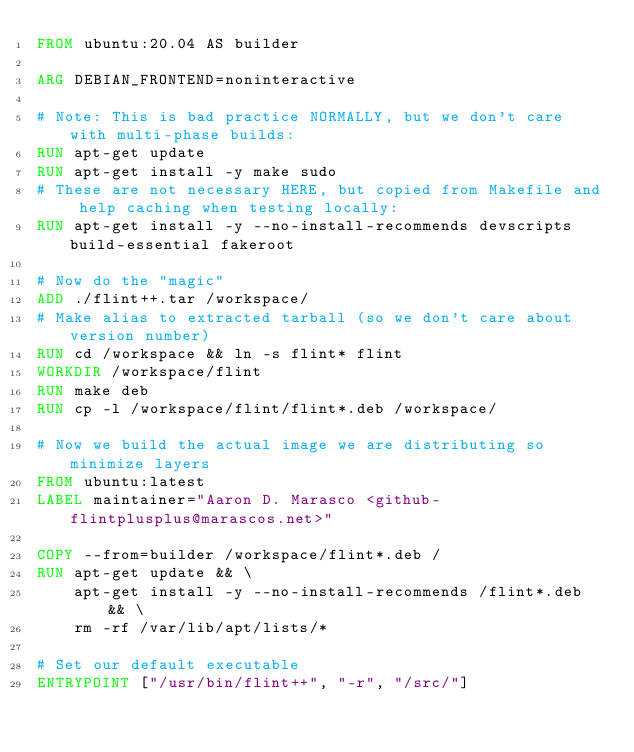<code> <loc_0><loc_0><loc_500><loc_500><_Dockerfile_>FROM ubuntu:20.04 AS builder

ARG DEBIAN_FRONTEND=noninteractive

# Note: This is bad practice NORMALLY, but we don't care with multi-phase builds:
RUN apt-get update
RUN apt-get install -y make sudo
# These are not necessary HERE, but copied from Makefile and help caching when testing locally:
RUN apt-get install -y --no-install-recommends devscripts build-essential fakeroot

# Now do the "magic"
ADD ./flint++.tar /workspace/
# Make alias to extracted tarball (so we don't care about version number)
RUN cd /workspace && ln -s flint* flint
WORKDIR /workspace/flint
RUN make deb
RUN cp -l /workspace/flint/flint*.deb /workspace/

# Now we build the actual image we are distributing so minimize layers
FROM ubuntu:latest
LABEL maintainer="Aaron D. Marasco <github-flintplusplus@marascos.net>"

COPY --from=builder /workspace/flint*.deb /
RUN apt-get update && \
    apt-get install -y --no-install-recommends /flint*.deb && \
    rm -rf /var/lib/apt/lists/*

# Set our default executable
ENTRYPOINT ["/usr/bin/flint++", "-r", "/src/"]
</code> 